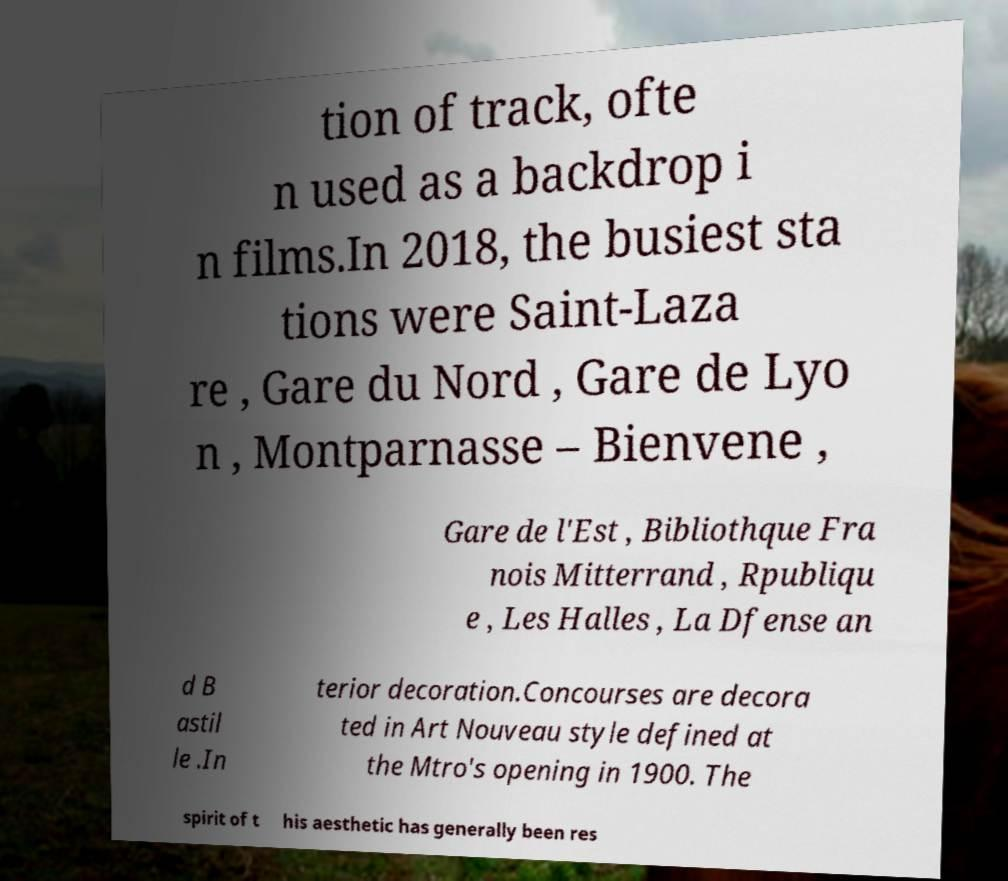Please read and relay the text visible in this image. What does it say? tion of track, ofte n used as a backdrop i n films.In 2018, the busiest sta tions were Saint-Laza re , Gare du Nord , Gare de Lyo n , Montparnasse – Bienvene , Gare de l'Est , Bibliothque Fra nois Mitterrand , Rpubliqu e , Les Halles , La Dfense an d B astil le .In terior decoration.Concourses are decora ted in Art Nouveau style defined at the Mtro's opening in 1900. The spirit of t his aesthetic has generally been res 